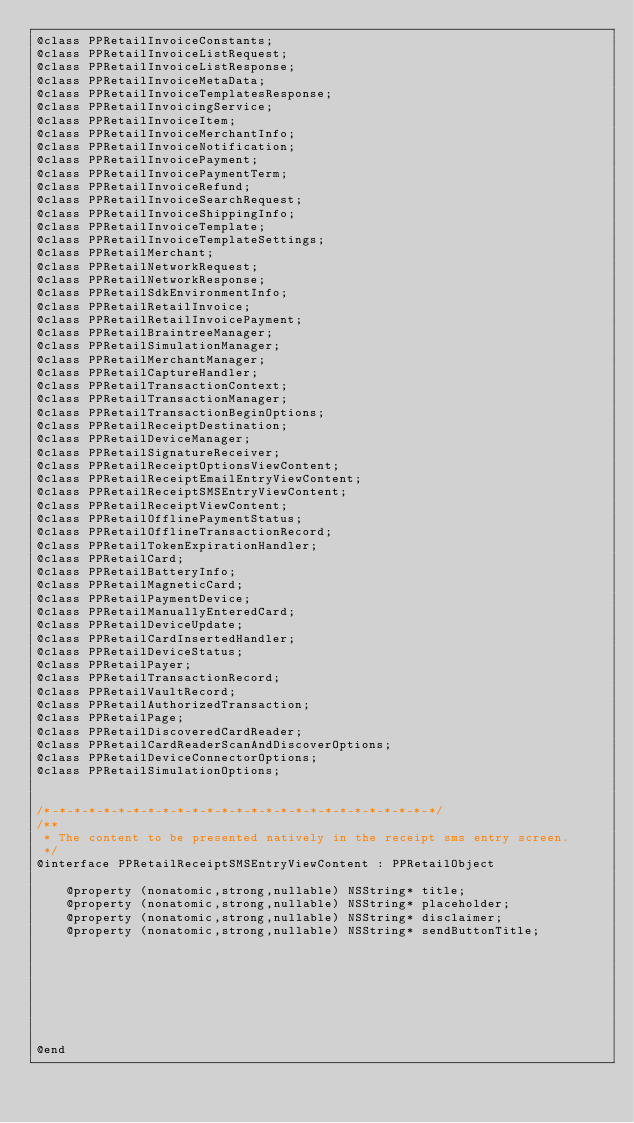<code> <loc_0><loc_0><loc_500><loc_500><_C_>@class PPRetailInvoiceConstants;
@class PPRetailInvoiceListRequest;
@class PPRetailInvoiceListResponse;
@class PPRetailInvoiceMetaData;
@class PPRetailInvoiceTemplatesResponse;
@class PPRetailInvoicingService;
@class PPRetailInvoiceItem;
@class PPRetailInvoiceMerchantInfo;
@class PPRetailInvoiceNotification;
@class PPRetailInvoicePayment;
@class PPRetailInvoicePaymentTerm;
@class PPRetailInvoiceRefund;
@class PPRetailInvoiceSearchRequest;
@class PPRetailInvoiceShippingInfo;
@class PPRetailInvoiceTemplate;
@class PPRetailInvoiceTemplateSettings;
@class PPRetailMerchant;
@class PPRetailNetworkRequest;
@class PPRetailNetworkResponse;
@class PPRetailSdkEnvironmentInfo;
@class PPRetailRetailInvoice;
@class PPRetailRetailInvoicePayment;
@class PPRetailBraintreeManager;
@class PPRetailSimulationManager;
@class PPRetailMerchantManager;
@class PPRetailCaptureHandler;
@class PPRetailTransactionContext;
@class PPRetailTransactionManager;
@class PPRetailTransactionBeginOptions;
@class PPRetailReceiptDestination;
@class PPRetailDeviceManager;
@class PPRetailSignatureReceiver;
@class PPRetailReceiptOptionsViewContent;
@class PPRetailReceiptEmailEntryViewContent;
@class PPRetailReceiptSMSEntryViewContent;
@class PPRetailReceiptViewContent;
@class PPRetailOfflinePaymentStatus;
@class PPRetailOfflineTransactionRecord;
@class PPRetailTokenExpirationHandler;
@class PPRetailCard;
@class PPRetailBatteryInfo;
@class PPRetailMagneticCard;
@class PPRetailPaymentDevice;
@class PPRetailManuallyEnteredCard;
@class PPRetailDeviceUpdate;
@class PPRetailCardInsertedHandler;
@class PPRetailDeviceStatus;
@class PPRetailPayer;
@class PPRetailTransactionRecord;
@class PPRetailVaultRecord;
@class PPRetailAuthorizedTransaction;
@class PPRetailPage;
@class PPRetailDiscoveredCardReader;
@class PPRetailCardReaderScanAndDiscoverOptions;
@class PPRetailDeviceConnectorOptions;
@class PPRetailSimulationOptions;


/*-*-*-*-*-*-*-*-*-*-*-*-*-*-*-*-*-*-*-*-*-*-*-*-*-*-*/
/**
 * The content to be presented natively in the receipt sms entry screen.
 */
@interface PPRetailReceiptSMSEntryViewContent : PPRetailObject

    @property (nonatomic,strong,nullable) NSString* title;
    @property (nonatomic,strong,nullable) NSString* placeholder;
    @property (nonatomic,strong,nullable) NSString* disclaimer;
    @property (nonatomic,strong,nullable) NSString* sendButtonTitle;








@end
</code> 